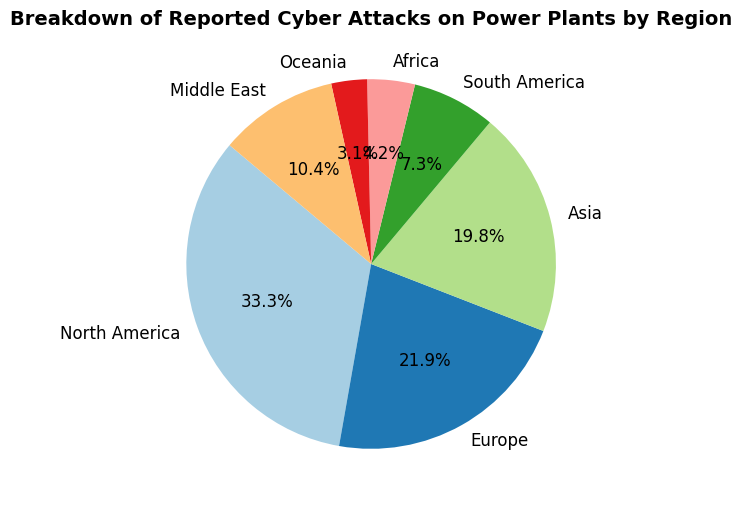What region shows the highest percentage of cyber attacks? By looking at the figure, we can see that the largest portion of the pie chart is labeled as North America. This indicates that North America has the highest percentage of cyber attacks.
Answer: North America Which region has the smallest share of reported cyber attacks? The smallest portion of the pie chart is labeled as Oceania. This indicates that Oceania has the smallest share of reported cyber attacks.
Answer: Oceania What percentage of cyber attacks occurred in Europe? By examining the text labels on the pie chart, we find that the segment representing Europe shows 210 attacks which equals 25.4%.
Answer: 25.4% Compare the number of cyber attacks in North America and Asia. Which region has more attacks and by how much? North America has 320 attacks while Asia has 190 attacks. The difference is 320 - 190 = 130 attacks. Hence, North America has 130 more attacks than Asia.
Answer: North America, 130 How many more cyber attacks were reported in North America than South America? North America has 320 attacks, and South America has 70 attacks. The difference is 320 - 70 = 250. So, North America has 250 more attacks than South America.
Answer: 250 What is the combined percentage of cyber attacks in Africa and Oceania? By referring to the figure, Africa has a portion of 3.1% and Oceania has 2.3%. Combining them: 3.1% + 2.3% = 5.4%.
Answer: 5.4% Which regions have fewer than 100 reported cyber attacks? The pie chart shows that South America, Africa, and Oceania have fewer than 100 attacks. Specifically, South America has 70, Africa has 40, and Oceania has 30.
Answer: South America, Africa, Oceania What is the percentage of cyber attacks reported across Europe, Asia, and the Middle East combined? Europe has 25.4%, Asia has 23.0%, and the Middle East has 12.1%. Adding them together: 25.4% + 23.0% + 12.1% = 60.5%. Therefore, these three regions combined account for 60.5% of the attacks.
Answer: 60.5% What regions have more than a 10% share of reported cyber attacks? By examining the pie chart, North America, Europe, and Asia, each have more than a 10% share. Specifically: North America has 38.5%, Europe has 25.4%, and Asia has 22.9%.
Answer: North America, Europe, Asia 